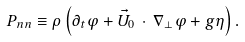<formula> <loc_0><loc_0><loc_500><loc_500>P _ { n n } \equiv \rho \left ( \partial _ { t } \varphi + \vec { U } _ { 0 } \, \cdot \, \nabla _ { \perp } \varphi + g \eta \right ) .</formula> 